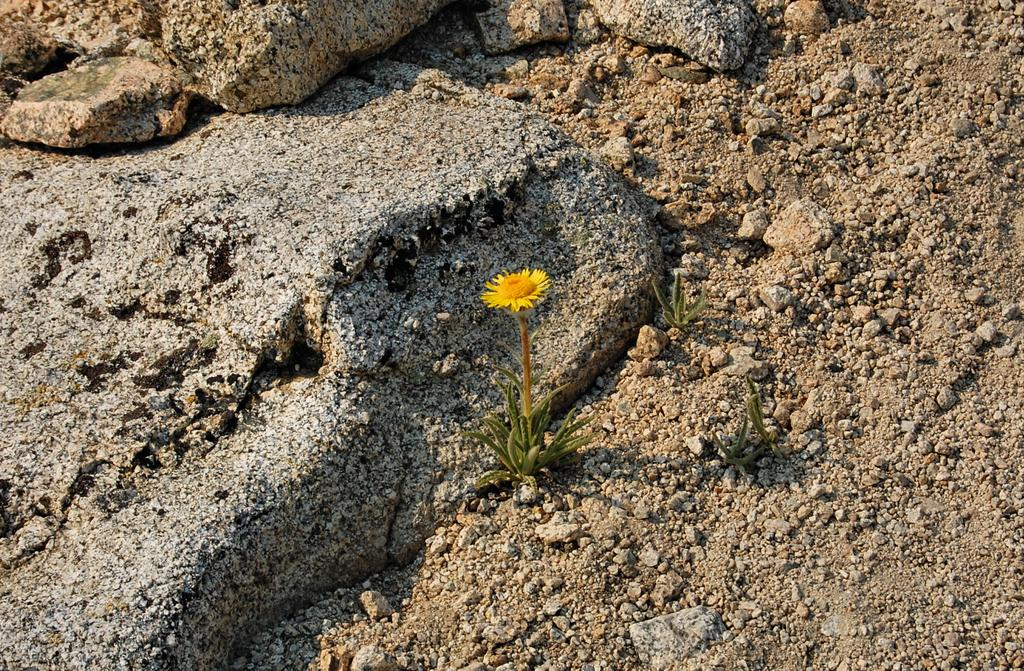What type of living organisms can be seen in the image? Plants and a flower are visible in the image. What other elements can be seen in the image besides plants and a flower? Rocks and soil are present in the image. What type of creature can be seen interacting with the flower in the image? There is no creature present in the image; it only features plants, a flower, rocks, and soil. How many arches can be seen in the image? There are no arches present in the image. 